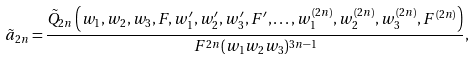Convert formula to latex. <formula><loc_0><loc_0><loc_500><loc_500>\tilde { a } _ { 2 n } = \frac { \tilde { Q } _ { 2 n } \left ( w _ { 1 } , w _ { 2 } , w _ { 3 } , F , w _ { 1 } ^ { \prime } , w _ { 2 } ^ { \prime } , w _ { 3 } ^ { \prime } , F ^ { \prime } , \dots , w _ { 1 } ^ { ( 2 n ) } , w _ { 2 } ^ { ( 2 n ) } , w _ { 3 } ^ { ( 2 n ) } , F ^ { ( 2 n ) } \right ) } { F ^ { 2 n } ( w _ { 1 } w _ { 2 } w _ { 3 } ) ^ { 3 n - 1 } } ,</formula> 